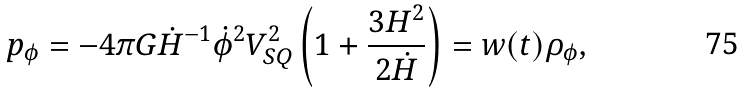Convert formula to latex. <formula><loc_0><loc_0><loc_500><loc_500>p _ { \phi } = - 4 \pi G \dot { H } ^ { - 1 } \dot { \phi } ^ { 2 } V _ { S Q } ^ { 2 } \left ( 1 + \frac { 3 H ^ { 2 } } { 2 \dot { H } } \right ) = w ( t ) \rho _ { \phi } ,</formula> 